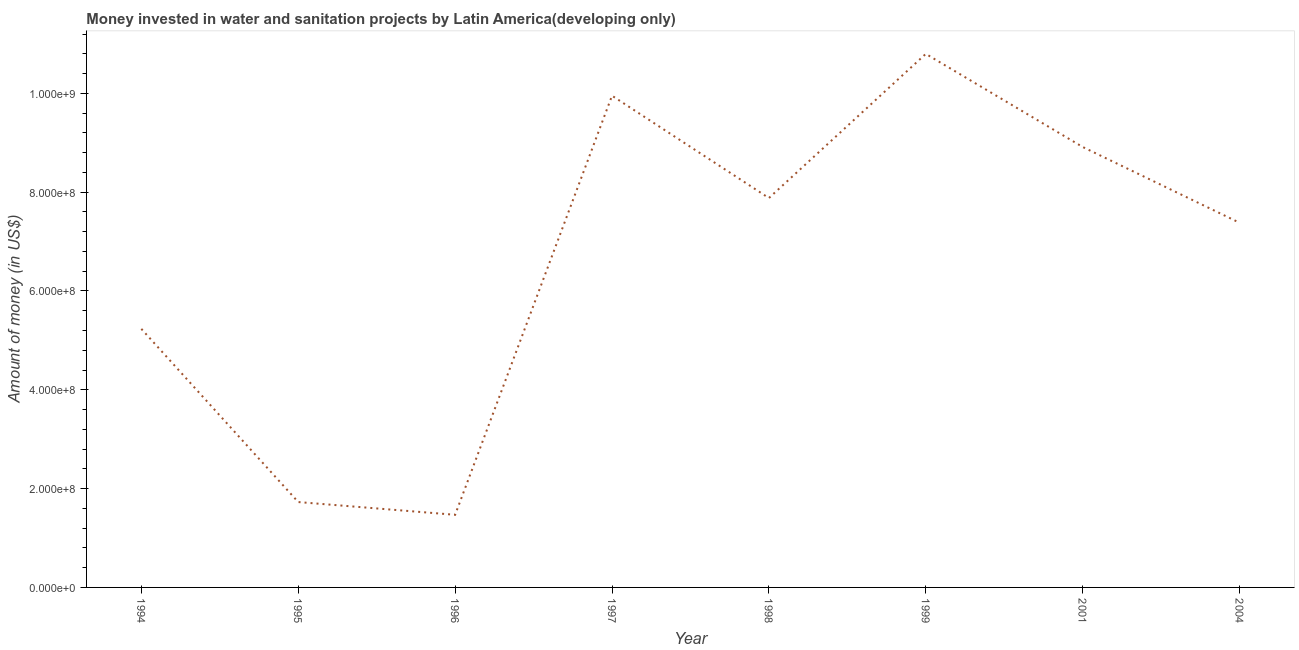What is the investment in 1995?
Provide a short and direct response. 1.73e+08. Across all years, what is the maximum investment?
Give a very brief answer. 1.08e+09. Across all years, what is the minimum investment?
Keep it short and to the point. 1.47e+08. In which year was the investment maximum?
Offer a very short reply. 1999. What is the sum of the investment?
Provide a succinct answer. 5.34e+09. What is the difference between the investment in 1994 and 1999?
Provide a short and direct response. -5.57e+08. What is the average investment per year?
Give a very brief answer. 6.67e+08. What is the median investment?
Provide a short and direct response. 7.63e+08. Do a majority of the years between 1996 and 1997 (inclusive) have investment greater than 440000000 US$?
Keep it short and to the point. No. What is the ratio of the investment in 1996 to that in 1998?
Your answer should be very brief. 0.19. Is the investment in 1994 less than that in 2004?
Offer a very short reply. Yes. Is the difference between the investment in 2001 and 2004 greater than the difference between any two years?
Ensure brevity in your answer.  No. What is the difference between the highest and the second highest investment?
Provide a short and direct response. 8.47e+07. What is the difference between the highest and the lowest investment?
Provide a short and direct response. 9.33e+08. In how many years, is the investment greater than the average investment taken over all years?
Keep it short and to the point. 5. How many lines are there?
Your answer should be very brief. 1. How many years are there in the graph?
Keep it short and to the point. 8. What is the difference between two consecutive major ticks on the Y-axis?
Ensure brevity in your answer.  2.00e+08. Does the graph contain any zero values?
Provide a succinct answer. No. Does the graph contain grids?
Ensure brevity in your answer.  No. What is the title of the graph?
Keep it short and to the point. Money invested in water and sanitation projects by Latin America(developing only). What is the label or title of the X-axis?
Give a very brief answer. Year. What is the label or title of the Y-axis?
Ensure brevity in your answer.  Amount of money (in US$). What is the Amount of money (in US$) in 1994?
Make the answer very short. 5.23e+08. What is the Amount of money (in US$) in 1995?
Your answer should be compact. 1.73e+08. What is the Amount of money (in US$) in 1996?
Keep it short and to the point. 1.47e+08. What is the Amount of money (in US$) in 1997?
Offer a very short reply. 9.95e+08. What is the Amount of money (in US$) in 1998?
Provide a short and direct response. 7.88e+08. What is the Amount of money (in US$) of 1999?
Provide a short and direct response. 1.08e+09. What is the Amount of money (in US$) in 2001?
Keep it short and to the point. 8.91e+08. What is the Amount of money (in US$) of 2004?
Keep it short and to the point. 7.38e+08. What is the difference between the Amount of money (in US$) in 1994 and 1995?
Provide a succinct answer. 3.50e+08. What is the difference between the Amount of money (in US$) in 1994 and 1996?
Ensure brevity in your answer.  3.76e+08. What is the difference between the Amount of money (in US$) in 1994 and 1997?
Make the answer very short. -4.72e+08. What is the difference between the Amount of money (in US$) in 1994 and 1998?
Your response must be concise. -2.65e+08. What is the difference between the Amount of money (in US$) in 1994 and 1999?
Ensure brevity in your answer.  -5.57e+08. What is the difference between the Amount of money (in US$) in 1994 and 2001?
Offer a terse response. -3.68e+08. What is the difference between the Amount of money (in US$) in 1994 and 2004?
Your answer should be compact. -2.15e+08. What is the difference between the Amount of money (in US$) in 1995 and 1996?
Keep it short and to the point. 2.58e+07. What is the difference between the Amount of money (in US$) in 1995 and 1997?
Ensure brevity in your answer.  -8.22e+08. What is the difference between the Amount of money (in US$) in 1995 and 1998?
Ensure brevity in your answer.  -6.15e+08. What is the difference between the Amount of money (in US$) in 1995 and 1999?
Keep it short and to the point. -9.07e+08. What is the difference between the Amount of money (in US$) in 1995 and 2001?
Keep it short and to the point. -7.19e+08. What is the difference between the Amount of money (in US$) in 1995 and 2004?
Offer a very short reply. -5.65e+08. What is the difference between the Amount of money (in US$) in 1996 and 1997?
Provide a succinct answer. -8.48e+08. What is the difference between the Amount of money (in US$) in 1996 and 1998?
Provide a short and direct response. -6.41e+08. What is the difference between the Amount of money (in US$) in 1996 and 1999?
Your response must be concise. -9.33e+08. What is the difference between the Amount of money (in US$) in 1996 and 2001?
Make the answer very short. -7.44e+08. What is the difference between the Amount of money (in US$) in 1996 and 2004?
Provide a short and direct response. -5.91e+08. What is the difference between the Amount of money (in US$) in 1997 and 1998?
Your answer should be compact. 2.07e+08. What is the difference between the Amount of money (in US$) in 1997 and 1999?
Your answer should be compact. -8.47e+07. What is the difference between the Amount of money (in US$) in 1997 and 2001?
Your response must be concise. 1.04e+08. What is the difference between the Amount of money (in US$) in 1997 and 2004?
Provide a succinct answer. 2.57e+08. What is the difference between the Amount of money (in US$) in 1998 and 1999?
Offer a terse response. -2.92e+08. What is the difference between the Amount of money (in US$) in 1998 and 2001?
Keep it short and to the point. -1.03e+08. What is the difference between the Amount of money (in US$) in 1998 and 2004?
Provide a succinct answer. 5.01e+07. What is the difference between the Amount of money (in US$) in 1999 and 2001?
Your answer should be compact. 1.88e+08. What is the difference between the Amount of money (in US$) in 1999 and 2004?
Your response must be concise. 3.42e+08. What is the difference between the Amount of money (in US$) in 2001 and 2004?
Provide a short and direct response. 1.53e+08. What is the ratio of the Amount of money (in US$) in 1994 to that in 1995?
Provide a short and direct response. 3.03. What is the ratio of the Amount of money (in US$) in 1994 to that in 1996?
Make the answer very short. 3.56. What is the ratio of the Amount of money (in US$) in 1994 to that in 1997?
Provide a succinct answer. 0.53. What is the ratio of the Amount of money (in US$) in 1994 to that in 1998?
Provide a short and direct response. 0.66. What is the ratio of the Amount of money (in US$) in 1994 to that in 1999?
Offer a terse response. 0.48. What is the ratio of the Amount of money (in US$) in 1994 to that in 2001?
Provide a succinct answer. 0.59. What is the ratio of the Amount of money (in US$) in 1994 to that in 2004?
Ensure brevity in your answer.  0.71. What is the ratio of the Amount of money (in US$) in 1995 to that in 1996?
Your answer should be very brief. 1.18. What is the ratio of the Amount of money (in US$) in 1995 to that in 1997?
Provide a succinct answer. 0.17. What is the ratio of the Amount of money (in US$) in 1995 to that in 1998?
Offer a very short reply. 0.22. What is the ratio of the Amount of money (in US$) in 1995 to that in 1999?
Offer a terse response. 0.16. What is the ratio of the Amount of money (in US$) in 1995 to that in 2001?
Your response must be concise. 0.19. What is the ratio of the Amount of money (in US$) in 1995 to that in 2004?
Give a very brief answer. 0.23. What is the ratio of the Amount of money (in US$) in 1996 to that in 1997?
Offer a very short reply. 0.15. What is the ratio of the Amount of money (in US$) in 1996 to that in 1998?
Your response must be concise. 0.19. What is the ratio of the Amount of money (in US$) in 1996 to that in 1999?
Your answer should be compact. 0.14. What is the ratio of the Amount of money (in US$) in 1996 to that in 2001?
Your response must be concise. 0.17. What is the ratio of the Amount of money (in US$) in 1996 to that in 2004?
Give a very brief answer. 0.2. What is the ratio of the Amount of money (in US$) in 1997 to that in 1998?
Ensure brevity in your answer.  1.26. What is the ratio of the Amount of money (in US$) in 1997 to that in 1999?
Keep it short and to the point. 0.92. What is the ratio of the Amount of money (in US$) in 1997 to that in 2001?
Offer a terse response. 1.12. What is the ratio of the Amount of money (in US$) in 1997 to that in 2004?
Your response must be concise. 1.35. What is the ratio of the Amount of money (in US$) in 1998 to that in 1999?
Your answer should be compact. 0.73. What is the ratio of the Amount of money (in US$) in 1998 to that in 2001?
Offer a very short reply. 0.88. What is the ratio of the Amount of money (in US$) in 1998 to that in 2004?
Offer a very short reply. 1.07. What is the ratio of the Amount of money (in US$) in 1999 to that in 2001?
Your answer should be compact. 1.21. What is the ratio of the Amount of money (in US$) in 1999 to that in 2004?
Offer a very short reply. 1.46. What is the ratio of the Amount of money (in US$) in 2001 to that in 2004?
Your answer should be very brief. 1.21. 